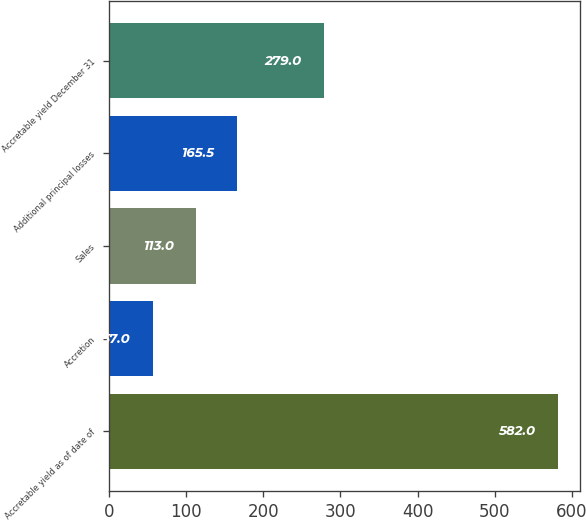Convert chart. <chart><loc_0><loc_0><loc_500><loc_500><bar_chart><fcel>Accretable yield as of date of<fcel>Accretion<fcel>Sales<fcel>Additional principal losses<fcel>Accretable yield December 31<nl><fcel>582<fcel>57<fcel>113<fcel>165.5<fcel>279<nl></chart> 